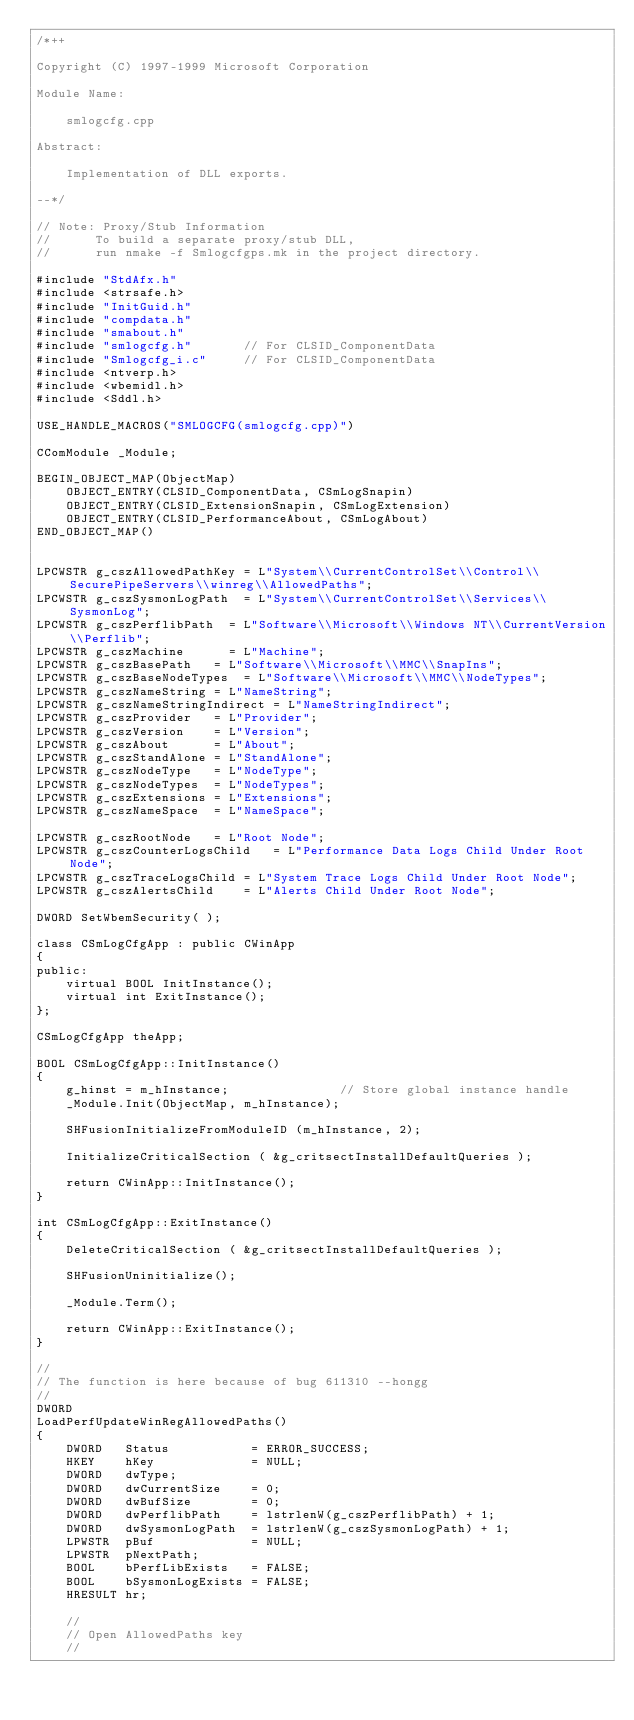Convert code to text. <code><loc_0><loc_0><loc_500><loc_500><_C++_>/*++

Copyright (C) 1997-1999 Microsoft Corporation

Module Name:

    smlogcfg.cpp

Abstract:

    Implementation of DLL exports.

--*/

// Note: Proxy/Stub Information
//      To build a separate proxy/stub DLL, 
//      run nmake -f Smlogcfgps.mk in the project directory.

#include "StdAfx.h"
#include <strsafe.h>
#include "InitGuid.h"
#include "compdata.h"
#include "smabout.h"
#include "smlogcfg.h"       // For CLSID_ComponentData
#include "Smlogcfg_i.c"     // For CLSID_ComponentData
#include <ntverp.h>
#include <wbemidl.h>
#include <Sddl.h>

USE_HANDLE_MACROS("SMLOGCFG(smlogcfg.cpp)")

CComModule _Module;

BEGIN_OBJECT_MAP(ObjectMap)
    OBJECT_ENTRY(CLSID_ComponentData, CSmLogSnapin)
    OBJECT_ENTRY(CLSID_ExtensionSnapin, CSmLogExtension)
    OBJECT_ENTRY(CLSID_PerformanceAbout, CSmLogAbout)
END_OBJECT_MAP()


LPCWSTR g_cszAllowedPathKey = L"System\\CurrentControlSet\\Control\\SecurePipeServers\\winreg\\AllowedPaths";
LPCWSTR g_cszSysmonLogPath  = L"System\\CurrentControlSet\\Services\\SysmonLog";
LPCWSTR g_cszPerflibPath  = L"Software\\Microsoft\\Windows NT\\CurrentVersion\\Perflib";
LPCWSTR g_cszMachine      = L"Machine";
LPCWSTR g_cszBasePath   = L"Software\\Microsoft\\MMC\\SnapIns";
LPCWSTR g_cszBaseNodeTypes  = L"Software\\Microsoft\\MMC\\NodeTypes";
LPCWSTR g_cszNameString = L"NameString";
LPCWSTR g_cszNameStringIndirect = L"NameStringIndirect";
LPCWSTR g_cszProvider   = L"Provider";
LPCWSTR g_cszVersion    = L"Version";
LPCWSTR g_cszAbout      = L"About";
LPCWSTR g_cszStandAlone = L"StandAlone";
LPCWSTR g_cszNodeType   = L"NodeType";
LPCWSTR g_cszNodeTypes  = L"NodeTypes";
LPCWSTR g_cszExtensions = L"Extensions";
LPCWSTR g_cszNameSpace  = L"NameSpace";

LPCWSTR g_cszRootNode   = L"Root Node";
LPCWSTR g_cszCounterLogsChild   = L"Performance Data Logs Child Under Root Node";
LPCWSTR g_cszTraceLogsChild = L"System Trace Logs Child Under Root Node";
LPCWSTR g_cszAlertsChild    = L"Alerts Child Under Root Node";

DWORD SetWbemSecurity( );

class CSmLogCfgApp : public CWinApp
{
public:
    virtual BOOL InitInstance();
    virtual int ExitInstance();
};

CSmLogCfgApp theApp;

BOOL CSmLogCfgApp::InitInstance()
{
    g_hinst = m_hInstance;               // Store global instance handle
    _Module.Init(ObjectMap, m_hInstance);

    SHFusionInitializeFromModuleID (m_hInstance, 2);
    
    InitializeCriticalSection ( &g_critsectInstallDefaultQueries );
    
    return CWinApp::InitInstance();
}

int CSmLogCfgApp::ExitInstance()
{
    DeleteCriticalSection ( &g_critsectInstallDefaultQueries );
    
    SHFusionUninitialize();
    
    _Module.Term();
    
    return CWinApp::ExitInstance();
}

//
// The function is here because of bug 611310 --hongg
//
DWORD 
LoadPerfUpdateWinRegAllowedPaths()
{
    DWORD   Status           = ERROR_SUCCESS;
    HKEY    hKey             = NULL;
    DWORD   dwType;
    DWORD   dwCurrentSize    = 0;
    DWORD   dwBufSize        = 0;
    DWORD   dwPerflibPath    = lstrlenW(g_cszPerflibPath) + 1;
    DWORD   dwSysmonLogPath  = lstrlenW(g_cszSysmonLogPath) + 1;
    LPWSTR  pBuf             = NULL;
    LPWSTR  pNextPath;
    BOOL    bPerfLibExists   = FALSE;
    BOOL    bSysmonLogExists = FALSE;
    HRESULT hr;

    //
    // Open AllowedPaths key
    //</code> 